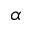<formula> <loc_0><loc_0><loc_500><loc_500>\alpha</formula> 